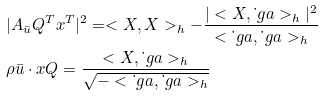<formula> <loc_0><loc_0><loc_500><loc_500>& | A _ { \bar { u } } Q ^ { T } x ^ { T } | ^ { 2 } = < X , X > _ { h } - \frac { | < X , \dot { \ } g a > _ { h } | ^ { 2 } } { < \dot { \ } g a , \dot { \ } g a > _ { h } } \\ & \rho \bar { u } \cdot x Q = \frac { < X , \dot { \ } g a > _ { h } } { \sqrt { - < \dot { \ } g a , \dot { \ } g a > _ { h } } }</formula> 